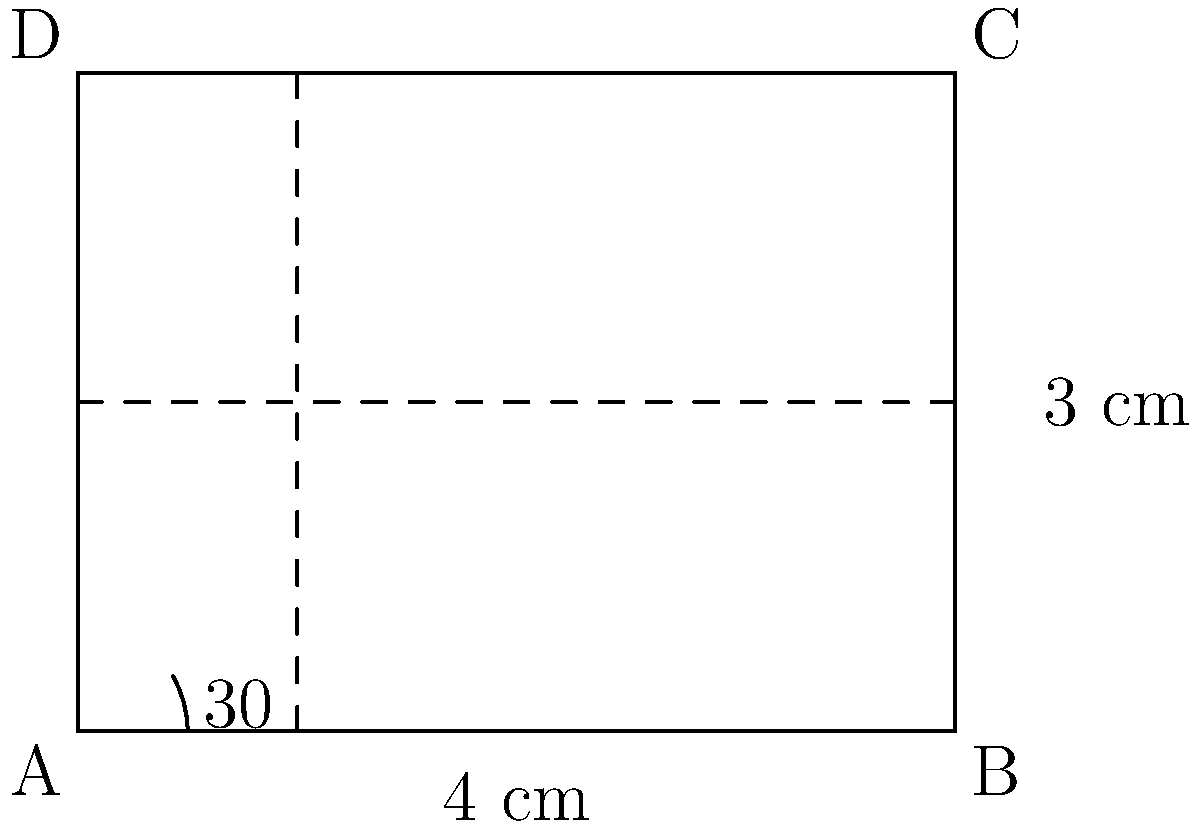You're designing a new jersey for a local sports team and want to incorporate angled stripes. The jersey is rectangular with a width of 4 cm and a height of 3 cm. If you want the stripes to be at a 30° angle from the bottom edge, what is the vertical distance between two consecutive stripes to ensure they are evenly spaced across the entire jersey? To solve this problem, we'll use trigonometry. Let's break it down step-by-step:

1) First, we need to understand what the 30° angle means in this context. It's the angle between the stripe and the bottom edge of the jersey.

2) We can use the tangent function to relate the vertical rise to the horizontal run:

   $\tan(30°) = \frac{\text{vertical rise}}{\text{horizontal run}}$

3) We know the width of the jersey is 4 cm, which represents the horizontal run for a complete stripe pattern.

4) Let's call the vertical rise (the distance we're looking for) $x$. We can set up the equation:

   $\tan(30°) = \frac{x}{4}$

5) Solve for $x$:
   
   $x = 4 \tan(30°)$

6) We know that $\tan(30°) = \frac{1}{\sqrt{3}}$, so:

   $x = 4 \cdot \frac{1}{\sqrt{3}} = \frac{4}{\sqrt{3}}$

7) Simplify:
   
   $x = \frac{4}{\sqrt{3}} \cdot \frac{\sqrt{3}}{\sqrt{3}} = \frac{4\sqrt{3}}{3}$ cm

This is the vertical distance between two consecutive stripes that will ensure they are evenly spaced across the entire jersey.
Answer: $\frac{4\sqrt{3}}{3}$ cm 